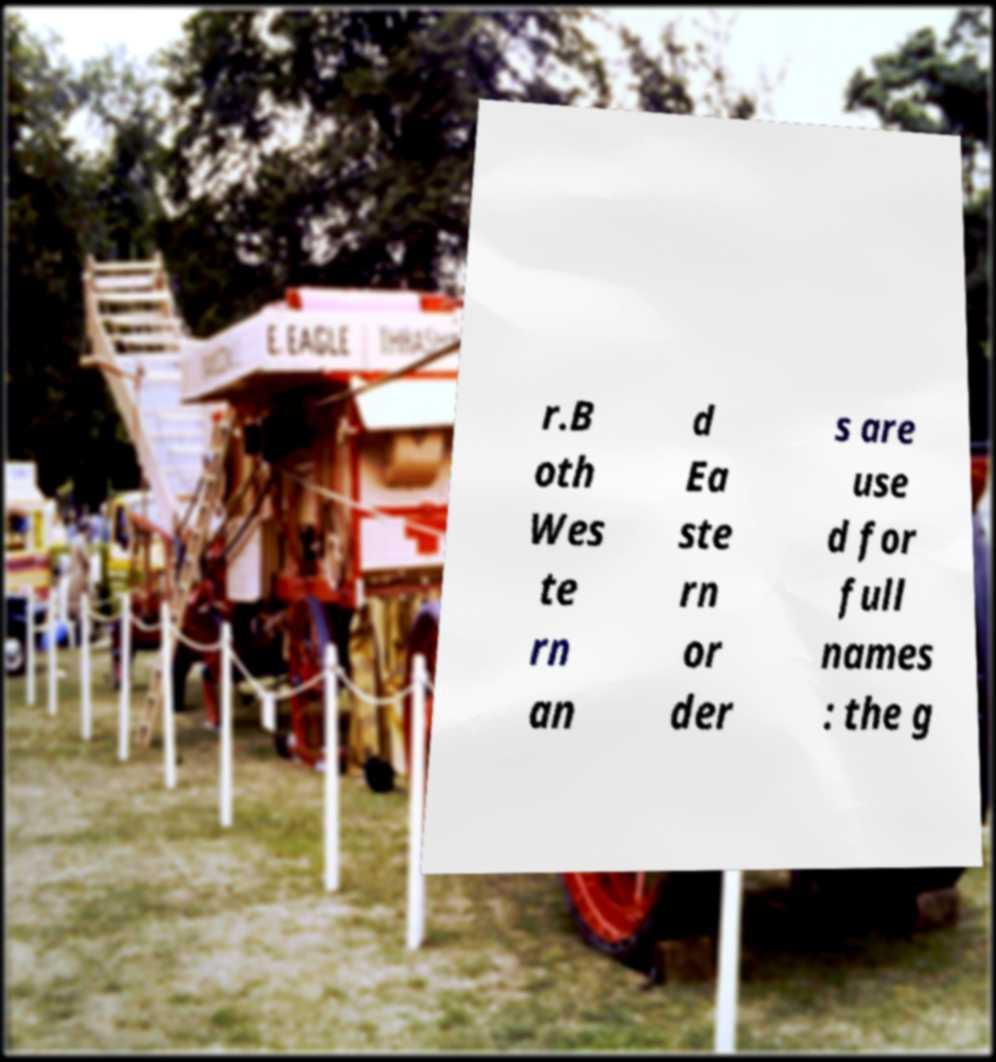Could you extract and type out the text from this image? r.B oth Wes te rn an d Ea ste rn or der s are use d for full names : the g 